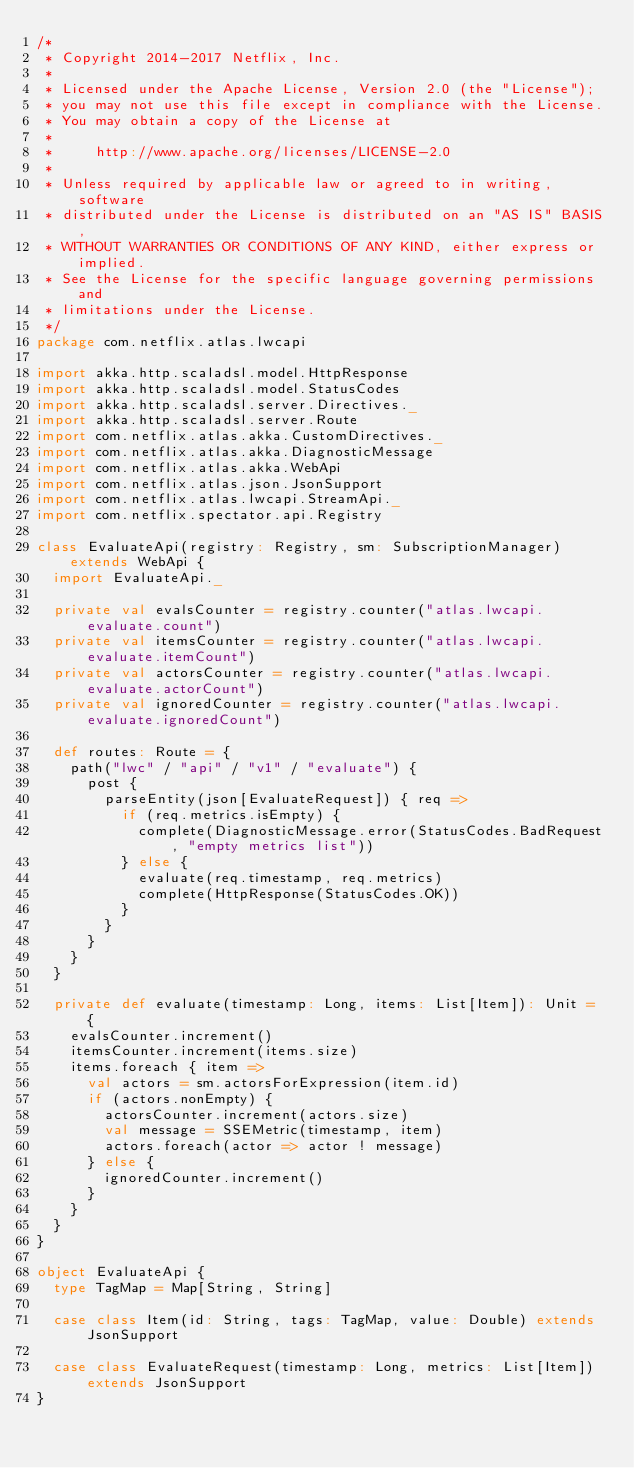<code> <loc_0><loc_0><loc_500><loc_500><_Scala_>/*
 * Copyright 2014-2017 Netflix, Inc.
 *
 * Licensed under the Apache License, Version 2.0 (the "License");
 * you may not use this file except in compliance with the License.
 * You may obtain a copy of the License at
 *
 *     http://www.apache.org/licenses/LICENSE-2.0
 *
 * Unless required by applicable law or agreed to in writing, software
 * distributed under the License is distributed on an "AS IS" BASIS,
 * WITHOUT WARRANTIES OR CONDITIONS OF ANY KIND, either express or implied.
 * See the License for the specific language governing permissions and
 * limitations under the License.
 */
package com.netflix.atlas.lwcapi

import akka.http.scaladsl.model.HttpResponse
import akka.http.scaladsl.model.StatusCodes
import akka.http.scaladsl.server.Directives._
import akka.http.scaladsl.server.Route
import com.netflix.atlas.akka.CustomDirectives._
import com.netflix.atlas.akka.DiagnosticMessage
import com.netflix.atlas.akka.WebApi
import com.netflix.atlas.json.JsonSupport
import com.netflix.atlas.lwcapi.StreamApi._
import com.netflix.spectator.api.Registry

class EvaluateApi(registry: Registry, sm: SubscriptionManager) extends WebApi {
  import EvaluateApi._

  private val evalsCounter = registry.counter("atlas.lwcapi.evaluate.count")
  private val itemsCounter = registry.counter("atlas.lwcapi.evaluate.itemCount")
  private val actorsCounter = registry.counter("atlas.lwcapi.evaluate.actorCount")
  private val ignoredCounter = registry.counter("atlas.lwcapi.evaluate.ignoredCount")

  def routes: Route = {
    path("lwc" / "api" / "v1" / "evaluate") {
      post {
        parseEntity(json[EvaluateRequest]) { req =>
          if (req.metrics.isEmpty) {
            complete(DiagnosticMessage.error(StatusCodes.BadRequest, "empty metrics list"))
          } else {
            evaluate(req.timestamp, req.metrics)
            complete(HttpResponse(StatusCodes.OK))
          }
        }
      }
    }
  }

  private def evaluate(timestamp: Long, items: List[Item]): Unit = {
    evalsCounter.increment()
    itemsCounter.increment(items.size)
    items.foreach { item =>
      val actors = sm.actorsForExpression(item.id)
      if (actors.nonEmpty) {
        actorsCounter.increment(actors.size)
        val message = SSEMetric(timestamp, item)
        actors.foreach(actor => actor ! message)
      } else {
        ignoredCounter.increment()
      }
    }
  }
}

object EvaluateApi {
  type TagMap = Map[String, String]

  case class Item(id: String, tags: TagMap, value: Double) extends JsonSupport

  case class EvaluateRequest(timestamp: Long, metrics: List[Item]) extends JsonSupport
}
</code> 